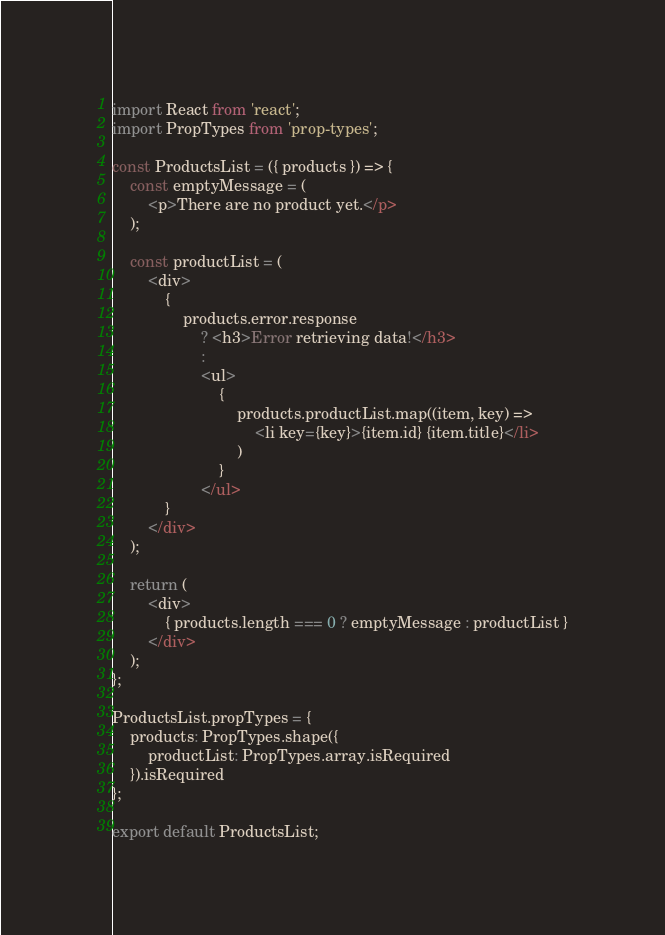Convert code to text. <code><loc_0><loc_0><loc_500><loc_500><_JavaScript_>import React from 'react';
import PropTypes from 'prop-types';

const ProductsList = ({ products }) => {
	const emptyMessage = (
		<p>There are no product yet.</p>
	);

	const productList = (
		<div>
			{
				products.error.response
					? <h3>Error retrieving data!</h3>
					:
					<ul>
						{
							products.productList.map((item, key) =>
								<li key={key}>{item.id} {item.title}</li>
							)
						}
					</ul>
			}
		</div>
	);

	return (
		<div>
			{ products.length === 0 ? emptyMessage : productList }
		</div>
	);
};

ProductsList.propTypes = {
	products: PropTypes.shape({
		productList: PropTypes.array.isRequired
	}).isRequired	
};

export default ProductsList;</code> 